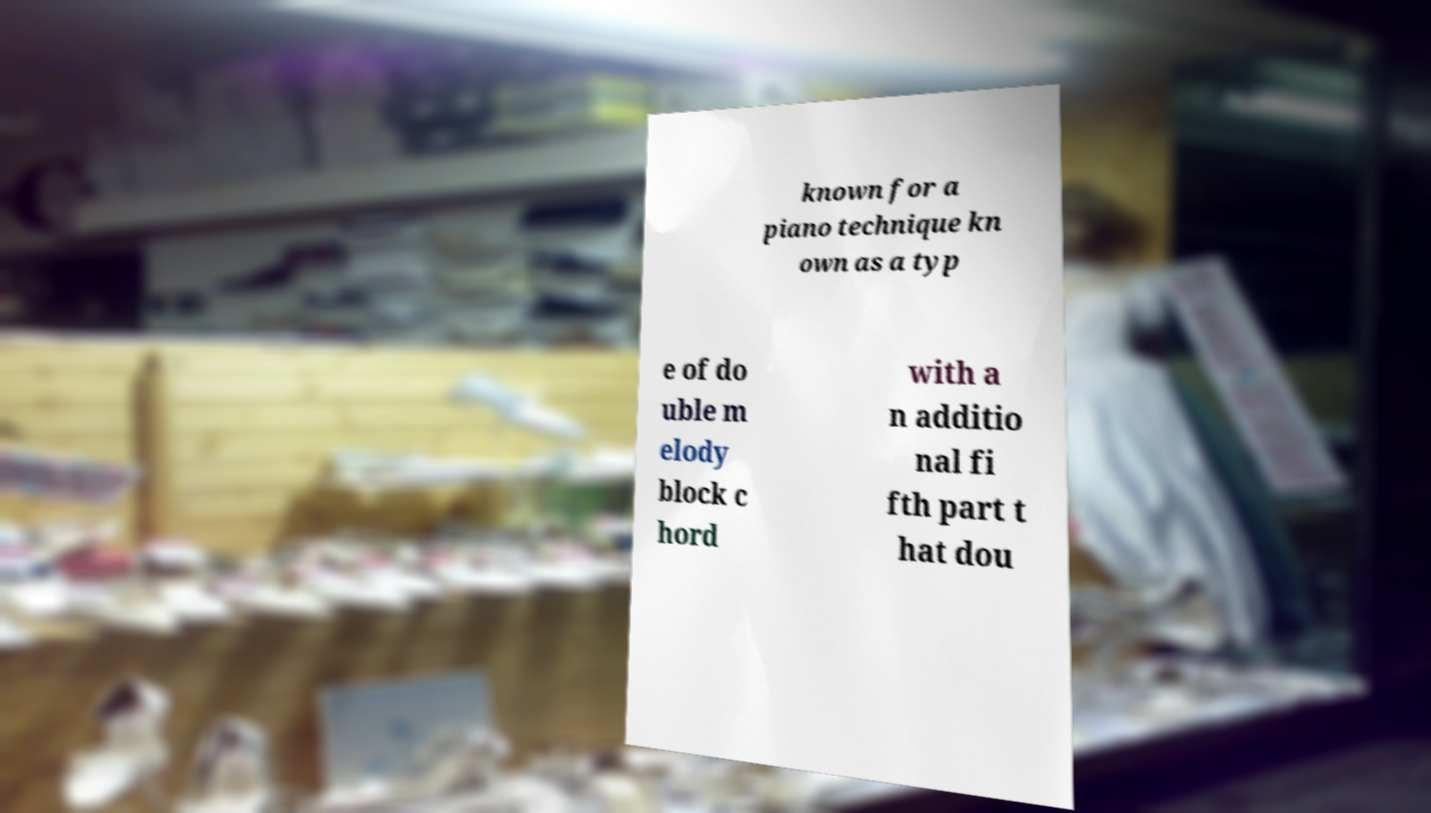I need the written content from this picture converted into text. Can you do that? known for a piano technique kn own as a typ e of do uble m elody block c hord with a n additio nal fi fth part t hat dou 